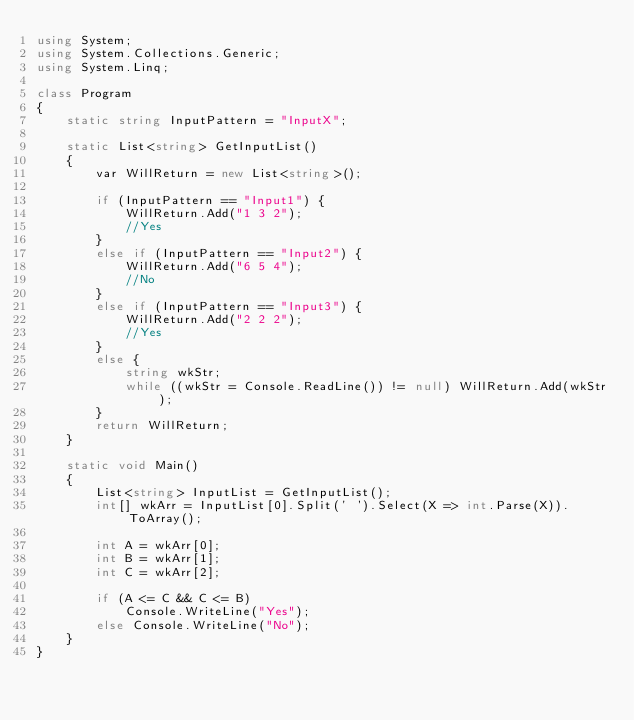<code> <loc_0><loc_0><loc_500><loc_500><_C#_>using System;
using System.Collections.Generic;
using System.Linq;

class Program
{
    static string InputPattern = "InputX";

    static List<string> GetInputList()
    {
        var WillReturn = new List<string>();

        if (InputPattern == "Input1") {
            WillReturn.Add("1 3 2");
            //Yes
        }
        else if (InputPattern == "Input2") {
            WillReturn.Add("6 5 4");
            //No
        }
        else if (InputPattern == "Input3") {
            WillReturn.Add("2 2 2");
            //Yes
        }
        else {
            string wkStr;
            while ((wkStr = Console.ReadLine()) != null) WillReturn.Add(wkStr);
        }
        return WillReturn;
    }

    static void Main()
    {
        List<string> InputList = GetInputList();
        int[] wkArr = InputList[0].Split(' ').Select(X => int.Parse(X)).ToArray();

        int A = wkArr[0];
        int B = wkArr[1];
        int C = wkArr[2];

        if (A <= C && C <= B)
            Console.WriteLine("Yes");
        else Console.WriteLine("No");
    }
}
</code> 